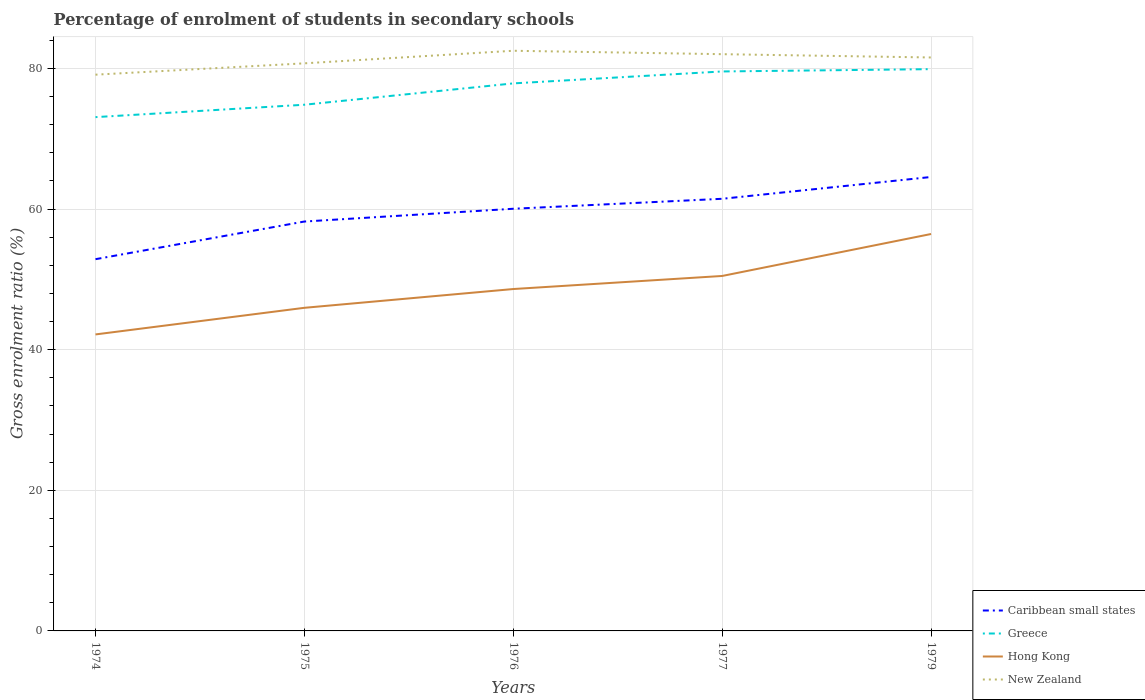How many different coloured lines are there?
Provide a short and direct response. 4. Does the line corresponding to New Zealand intersect with the line corresponding to Caribbean small states?
Offer a terse response. No. Is the number of lines equal to the number of legend labels?
Your response must be concise. Yes. Across all years, what is the maximum percentage of students enrolled in secondary schools in Greece?
Make the answer very short. 73.08. In which year was the percentage of students enrolled in secondary schools in Hong Kong maximum?
Provide a short and direct response. 1974. What is the total percentage of students enrolled in secondary schools in Caribbean small states in the graph?
Ensure brevity in your answer.  -1.42. What is the difference between the highest and the second highest percentage of students enrolled in secondary schools in New Zealand?
Give a very brief answer. 3.4. Is the percentage of students enrolled in secondary schools in Caribbean small states strictly greater than the percentage of students enrolled in secondary schools in Greece over the years?
Your answer should be compact. Yes. What is the difference between two consecutive major ticks on the Y-axis?
Provide a short and direct response. 20. Are the values on the major ticks of Y-axis written in scientific E-notation?
Offer a very short reply. No. Does the graph contain any zero values?
Provide a succinct answer. No. Does the graph contain grids?
Your answer should be compact. Yes. Where does the legend appear in the graph?
Give a very brief answer. Bottom right. How many legend labels are there?
Make the answer very short. 4. How are the legend labels stacked?
Offer a terse response. Vertical. What is the title of the graph?
Offer a terse response. Percentage of enrolment of students in secondary schools. Does "Sub-Saharan Africa (developing only)" appear as one of the legend labels in the graph?
Offer a terse response. No. What is the label or title of the X-axis?
Provide a succinct answer. Years. What is the label or title of the Y-axis?
Your response must be concise. Gross enrolment ratio (%). What is the Gross enrolment ratio (%) of Caribbean small states in 1974?
Provide a succinct answer. 52.88. What is the Gross enrolment ratio (%) in Greece in 1974?
Provide a succinct answer. 73.08. What is the Gross enrolment ratio (%) of Hong Kong in 1974?
Provide a short and direct response. 42.17. What is the Gross enrolment ratio (%) in New Zealand in 1974?
Your answer should be compact. 79.12. What is the Gross enrolment ratio (%) in Caribbean small states in 1975?
Provide a succinct answer. 58.23. What is the Gross enrolment ratio (%) in Greece in 1975?
Your response must be concise. 74.84. What is the Gross enrolment ratio (%) in Hong Kong in 1975?
Your response must be concise. 45.96. What is the Gross enrolment ratio (%) of New Zealand in 1975?
Keep it short and to the point. 80.73. What is the Gross enrolment ratio (%) of Caribbean small states in 1976?
Offer a terse response. 60.05. What is the Gross enrolment ratio (%) in Greece in 1976?
Your response must be concise. 77.88. What is the Gross enrolment ratio (%) of Hong Kong in 1976?
Provide a short and direct response. 48.63. What is the Gross enrolment ratio (%) of New Zealand in 1976?
Your answer should be compact. 82.52. What is the Gross enrolment ratio (%) of Caribbean small states in 1977?
Offer a very short reply. 61.46. What is the Gross enrolment ratio (%) in Greece in 1977?
Ensure brevity in your answer.  79.58. What is the Gross enrolment ratio (%) in Hong Kong in 1977?
Your answer should be very brief. 50.49. What is the Gross enrolment ratio (%) of New Zealand in 1977?
Your response must be concise. 82.03. What is the Gross enrolment ratio (%) of Caribbean small states in 1979?
Give a very brief answer. 64.57. What is the Gross enrolment ratio (%) in Greece in 1979?
Your response must be concise. 79.91. What is the Gross enrolment ratio (%) of Hong Kong in 1979?
Give a very brief answer. 56.46. What is the Gross enrolment ratio (%) in New Zealand in 1979?
Make the answer very short. 81.57. Across all years, what is the maximum Gross enrolment ratio (%) of Caribbean small states?
Your answer should be compact. 64.57. Across all years, what is the maximum Gross enrolment ratio (%) of Greece?
Give a very brief answer. 79.91. Across all years, what is the maximum Gross enrolment ratio (%) of Hong Kong?
Ensure brevity in your answer.  56.46. Across all years, what is the maximum Gross enrolment ratio (%) of New Zealand?
Give a very brief answer. 82.52. Across all years, what is the minimum Gross enrolment ratio (%) in Caribbean small states?
Provide a succinct answer. 52.88. Across all years, what is the minimum Gross enrolment ratio (%) in Greece?
Give a very brief answer. 73.08. Across all years, what is the minimum Gross enrolment ratio (%) in Hong Kong?
Offer a terse response. 42.17. Across all years, what is the minimum Gross enrolment ratio (%) in New Zealand?
Give a very brief answer. 79.12. What is the total Gross enrolment ratio (%) of Caribbean small states in the graph?
Make the answer very short. 297.19. What is the total Gross enrolment ratio (%) in Greece in the graph?
Offer a very short reply. 385.29. What is the total Gross enrolment ratio (%) of Hong Kong in the graph?
Your answer should be very brief. 243.71. What is the total Gross enrolment ratio (%) in New Zealand in the graph?
Ensure brevity in your answer.  405.97. What is the difference between the Gross enrolment ratio (%) in Caribbean small states in 1974 and that in 1975?
Make the answer very short. -5.36. What is the difference between the Gross enrolment ratio (%) of Greece in 1974 and that in 1975?
Keep it short and to the point. -1.76. What is the difference between the Gross enrolment ratio (%) of Hong Kong in 1974 and that in 1975?
Offer a terse response. -3.79. What is the difference between the Gross enrolment ratio (%) of New Zealand in 1974 and that in 1975?
Offer a terse response. -1.61. What is the difference between the Gross enrolment ratio (%) in Caribbean small states in 1974 and that in 1976?
Offer a terse response. -7.17. What is the difference between the Gross enrolment ratio (%) of Greece in 1974 and that in 1976?
Give a very brief answer. -4.8. What is the difference between the Gross enrolment ratio (%) of Hong Kong in 1974 and that in 1976?
Offer a very short reply. -6.46. What is the difference between the Gross enrolment ratio (%) in New Zealand in 1974 and that in 1976?
Offer a very short reply. -3.4. What is the difference between the Gross enrolment ratio (%) in Caribbean small states in 1974 and that in 1977?
Offer a very short reply. -8.59. What is the difference between the Gross enrolment ratio (%) in Greece in 1974 and that in 1977?
Give a very brief answer. -6.5. What is the difference between the Gross enrolment ratio (%) of Hong Kong in 1974 and that in 1977?
Give a very brief answer. -8.32. What is the difference between the Gross enrolment ratio (%) of New Zealand in 1974 and that in 1977?
Provide a short and direct response. -2.92. What is the difference between the Gross enrolment ratio (%) of Caribbean small states in 1974 and that in 1979?
Offer a terse response. -11.69. What is the difference between the Gross enrolment ratio (%) in Greece in 1974 and that in 1979?
Your response must be concise. -6.82. What is the difference between the Gross enrolment ratio (%) in Hong Kong in 1974 and that in 1979?
Your answer should be compact. -14.28. What is the difference between the Gross enrolment ratio (%) in New Zealand in 1974 and that in 1979?
Give a very brief answer. -2.45. What is the difference between the Gross enrolment ratio (%) in Caribbean small states in 1975 and that in 1976?
Your answer should be very brief. -1.82. What is the difference between the Gross enrolment ratio (%) in Greece in 1975 and that in 1976?
Offer a very short reply. -3.04. What is the difference between the Gross enrolment ratio (%) of Hong Kong in 1975 and that in 1976?
Your response must be concise. -2.67. What is the difference between the Gross enrolment ratio (%) in New Zealand in 1975 and that in 1976?
Keep it short and to the point. -1.79. What is the difference between the Gross enrolment ratio (%) in Caribbean small states in 1975 and that in 1977?
Give a very brief answer. -3.23. What is the difference between the Gross enrolment ratio (%) of Greece in 1975 and that in 1977?
Your answer should be compact. -4.73. What is the difference between the Gross enrolment ratio (%) in Hong Kong in 1975 and that in 1977?
Your response must be concise. -4.53. What is the difference between the Gross enrolment ratio (%) of New Zealand in 1975 and that in 1977?
Provide a short and direct response. -1.3. What is the difference between the Gross enrolment ratio (%) of Caribbean small states in 1975 and that in 1979?
Offer a terse response. -6.34. What is the difference between the Gross enrolment ratio (%) of Greece in 1975 and that in 1979?
Provide a short and direct response. -5.06. What is the difference between the Gross enrolment ratio (%) in Hong Kong in 1975 and that in 1979?
Provide a short and direct response. -10.5. What is the difference between the Gross enrolment ratio (%) of New Zealand in 1975 and that in 1979?
Make the answer very short. -0.83. What is the difference between the Gross enrolment ratio (%) in Caribbean small states in 1976 and that in 1977?
Your answer should be very brief. -1.42. What is the difference between the Gross enrolment ratio (%) in Greece in 1976 and that in 1977?
Offer a very short reply. -1.7. What is the difference between the Gross enrolment ratio (%) of Hong Kong in 1976 and that in 1977?
Offer a terse response. -1.86. What is the difference between the Gross enrolment ratio (%) of New Zealand in 1976 and that in 1977?
Your response must be concise. 0.49. What is the difference between the Gross enrolment ratio (%) in Caribbean small states in 1976 and that in 1979?
Offer a terse response. -4.52. What is the difference between the Gross enrolment ratio (%) in Greece in 1976 and that in 1979?
Your answer should be very brief. -2.03. What is the difference between the Gross enrolment ratio (%) in Hong Kong in 1976 and that in 1979?
Provide a short and direct response. -7.83. What is the difference between the Gross enrolment ratio (%) of New Zealand in 1976 and that in 1979?
Your answer should be compact. 0.96. What is the difference between the Gross enrolment ratio (%) of Caribbean small states in 1977 and that in 1979?
Provide a short and direct response. -3.1. What is the difference between the Gross enrolment ratio (%) of Greece in 1977 and that in 1979?
Ensure brevity in your answer.  -0.33. What is the difference between the Gross enrolment ratio (%) of Hong Kong in 1977 and that in 1979?
Your response must be concise. -5.97. What is the difference between the Gross enrolment ratio (%) in New Zealand in 1977 and that in 1979?
Provide a short and direct response. 0.47. What is the difference between the Gross enrolment ratio (%) of Caribbean small states in 1974 and the Gross enrolment ratio (%) of Greece in 1975?
Give a very brief answer. -21.97. What is the difference between the Gross enrolment ratio (%) of Caribbean small states in 1974 and the Gross enrolment ratio (%) of Hong Kong in 1975?
Offer a very short reply. 6.92. What is the difference between the Gross enrolment ratio (%) of Caribbean small states in 1974 and the Gross enrolment ratio (%) of New Zealand in 1975?
Ensure brevity in your answer.  -27.86. What is the difference between the Gross enrolment ratio (%) of Greece in 1974 and the Gross enrolment ratio (%) of Hong Kong in 1975?
Offer a terse response. 27.12. What is the difference between the Gross enrolment ratio (%) in Greece in 1974 and the Gross enrolment ratio (%) in New Zealand in 1975?
Offer a terse response. -7.65. What is the difference between the Gross enrolment ratio (%) of Hong Kong in 1974 and the Gross enrolment ratio (%) of New Zealand in 1975?
Make the answer very short. -38.56. What is the difference between the Gross enrolment ratio (%) of Caribbean small states in 1974 and the Gross enrolment ratio (%) of Greece in 1976?
Your answer should be very brief. -25. What is the difference between the Gross enrolment ratio (%) in Caribbean small states in 1974 and the Gross enrolment ratio (%) in Hong Kong in 1976?
Offer a terse response. 4.24. What is the difference between the Gross enrolment ratio (%) in Caribbean small states in 1974 and the Gross enrolment ratio (%) in New Zealand in 1976?
Provide a short and direct response. -29.65. What is the difference between the Gross enrolment ratio (%) in Greece in 1974 and the Gross enrolment ratio (%) in Hong Kong in 1976?
Make the answer very short. 24.45. What is the difference between the Gross enrolment ratio (%) in Greece in 1974 and the Gross enrolment ratio (%) in New Zealand in 1976?
Provide a short and direct response. -9.44. What is the difference between the Gross enrolment ratio (%) of Hong Kong in 1974 and the Gross enrolment ratio (%) of New Zealand in 1976?
Keep it short and to the point. -40.35. What is the difference between the Gross enrolment ratio (%) in Caribbean small states in 1974 and the Gross enrolment ratio (%) in Greece in 1977?
Your answer should be compact. -26.7. What is the difference between the Gross enrolment ratio (%) in Caribbean small states in 1974 and the Gross enrolment ratio (%) in Hong Kong in 1977?
Make the answer very short. 2.39. What is the difference between the Gross enrolment ratio (%) in Caribbean small states in 1974 and the Gross enrolment ratio (%) in New Zealand in 1977?
Your answer should be compact. -29.16. What is the difference between the Gross enrolment ratio (%) in Greece in 1974 and the Gross enrolment ratio (%) in Hong Kong in 1977?
Keep it short and to the point. 22.59. What is the difference between the Gross enrolment ratio (%) of Greece in 1974 and the Gross enrolment ratio (%) of New Zealand in 1977?
Make the answer very short. -8.95. What is the difference between the Gross enrolment ratio (%) of Hong Kong in 1974 and the Gross enrolment ratio (%) of New Zealand in 1977?
Give a very brief answer. -39.86. What is the difference between the Gross enrolment ratio (%) in Caribbean small states in 1974 and the Gross enrolment ratio (%) in Greece in 1979?
Your response must be concise. -27.03. What is the difference between the Gross enrolment ratio (%) in Caribbean small states in 1974 and the Gross enrolment ratio (%) in Hong Kong in 1979?
Provide a short and direct response. -3.58. What is the difference between the Gross enrolment ratio (%) in Caribbean small states in 1974 and the Gross enrolment ratio (%) in New Zealand in 1979?
Your response must be concise. -28.69. What is the difference between the Gross enrolment ratio (%) of Greece in 1974 and the Gross enrolment ratio (%) of Hong Kong in 1979?
Offer a very short reply. 16.62. What is the difference between the Gross enrolment ratio (%) in Greece in 1974 and the Gross enrolment ratio (%) in New Zealand in 1979?
Your answer should be compact. -8.48. What is the difference between the Gross enrolment ratio (%) in Hong Kong in 1974 and the Gross enrolment ratio (%) in New Zealand in 1979?
Your answer should be very brief. -39.39. What is the difference between the Gross enrolment ratio (%) of Caribbean small states in 1975 and the Gross enrolment ratio (%) of Greece in 1976?
Your answer should be very brief. -19.65. What is the difference between the Gross enrolment ratio (%) of Caribbean small states in 1975 and the Gross enrolment ratio (%) of Hong Kong in 1976?
Keep it short and to the point. 9.6. What is the difference between the Gross enrolment ratio (%) in Caribbean small states in 1975 and the Gross enrolment ratio (%) in New Zealand in 1976?
Your answer should be very brief. -24.29. What is the difference between the Gross enrolment ratio (%) in Greece in 1975 and the Gross enrolment ratio (%) in Hong Kong in 1976?
Offer a terse response. 26.21. What is the difference between the Gross enrolment ratio (%) of Greece in 1975 and the Gross enrolment ratio (%) of New Zealand in 1976?
Make the answer very short. -7.68. What is the difference between the Gross enrolment ratio (%) in Hong Kong in 1975 and the Gross enrolment ratio (%) in New Zealand in 1976?
Make the answer very short. -36.56. What is the difference between the Gross enrolment ratio (%) in Caribbean small states in 1975 and the Gross enrolment ratio (%) in Greece in 1977?
Your response must be concise. -21.35. What is the difference between the Gross enrolment ratio (%) in Caribbean small states in 1975 and the Gross enrolment ratio (%) in Hong Kong in 1977?
Ensure brevity in your answer.  7.74. What is the difference between the Gross enrolment ratio (%) in Caribbean small states in 1975 and the Gross enrolment ratio (%) in New Zealand in 1977?
Your answer should be very brief. -23.8. What is the difference between the Gross enrolment ratio (%) in Greece in 1975 and the Gross enrolment ratio (%) in Hong Kong in 1977?
Provide a short and direct response. 24.36. What is the difference between the Gross enrolment ratio (%) in Greece in 1975 and the Gross enrolment ratio (%) in New Zealand in 1977?
Your response must be concise. -7.19. What is the difference between the Gross enrolment ratio (%) of Hong Kong in 1975 and the Gross enrolment ratio (%) of New Zealand in 1977?
Your response must be concise. -36.08. What is the difference between the Gross enrolment ratio (%) in Caribbean small states in 1975 and the Gross enrolment ratio (%) in Greece in 1979?
Provide a succinct answer. -21.67. What is the difference between the Gross enrolment ratio (%) in Caribbean small states in 1975 and the Gross enrolment ratio (%) in Hong Kong in 1979?
Provide a short and direct response. 1.77. What is the difference between the Gross enrolment ratio (%) of Caribbean small states in 1975 and the Gross enrolment ratio (%) of New Zealand in 1979?
Keep it short and to the point. -23.33. What is the difference between the Gross enrolment ratio (%) of Greece in 1975 and the Gross enrolment ratio (%) of Hong Kong in 1979?
Your answer should be compact. 18.39. What is the difference between the Gross enrolment ratio (%) of Greece in 1975 and the Gross enrolment ratio (%) of New Zealand in 1979?
Give a very brief answer. -6.72. What is the difference between the Gross enrolment ratio (%) in Hong Kong in 1975 and the Gross enrolment ratio (%) in New Zealand in 1979?
Keep it short and to the point. -35.61. What is the difference between the Gross enrolment ratio (%) in Caribbean small states in 1976 and the Gross enrolment ratio (%) in Greece in 1977?
Give a very brief answer. -19.53. What is the difference between the Gross enrolment ratio (%) in Caribbean small states in 1976 and the Gross enrolment ratio (%) in Hong Kong in 1977?
Your answer should be compact. 9.56. What is the difference between the Gross enrolment ratio (%) in Caribbean small states in 1976 and the Gross enrolment ratio (%) in New Zealand in 1977?
Offer a very short reply. -21.99. What is the difference between the Gross enrolment ratio (%) of Greece in 1976 and the Gross enrolment ratio (%) of Hong Kong in 1977?
Your answer should be very brief. 27.39. What is the difference between the Gross enrolment ratio (%) in Greece in 1976 and the Gross enrolment ratio (%) in New Zealand in 1977?
Your answer should be compact. -4.16. What is the difference between the Gross enrolment ratio (%) in Hong Kong in 1976 and the Gross enrolment ratio (%) in New Zealand in 1977?
Keep it short and to the point. -33.4. What is the difference between the Gross enrolment ratio (%) in Caribbean small states in 1976 and the Gross enrolment ratio (%) in Greece in 1979?
Your answer should be very brief. -19.86. What is the difference between the Gross enrolment ratio (%) in Caribbean small states in 1976 and the Gross enrolment ratio (%) in Hong Kong in 1979?
Keep it short and to the point. 3.59. What is the difference between the Gross enrolment ratio (%) in Caribbean small states in 1976 and the Gross enrolment ratio (%) in New Zealand in 1979?
Provide a succinct answer. -21.52. What is the difference between the Gross enrolment ratio (%) of Greece in 1976 and the Gross enrolment ratio (%) of Hong Kong in 1979?
Provide a succinct answer. 21.42. What is the difference between the Gross enrolment ratio (%) in Greece in 1976 and the Gross enrolment ratio (%) in New Zealand in 1979?
Provide a short and direct response. -3.69. What is the difference between the Gross enrolment ratio (%) of Hong Kong in 1976 and the Gross enrolment ratio (%) of New Zealand in 1979?
Your response must be concise. -32.94. What is the difference between the Gross enrolment ratio (%) in Caribbean small states in 1977 and the Gross enrolment ratio (%) in Greece in 1979?
Give a very brief answer. -18.44. What is the difference between the Gross enrolment ratio (%) of Caribbean small states in 1977 and the Gross enrolment ratio (%) of Hong Kong in 1979?
Keep it short and to the point. 5.01. What is the difference between the Gross enrolment ratio (%) of Caribbean small states in 1977 and the Gross enrolment ratio (%) of New Zealand in 1979?
Offer a terse response. -20.1. What is the difference between the Gross enrolment ratio (%) in Greece in 1977 and the Gross enrolment ratio (%) in Hong Kong in 1979?
Provide a short and direct response. 23.12. What is the difference between the Gross enrolment ratio (%) of Greece in 1977 and the Gross enrolment ratio (%) of New Zealand in 1979?
Keep it short and to the point. -1.99. What is the difference between the Gross enrolment ratio (%) in Hong Kong in 1977 and the Gross enrolment ratio (%) in New Zealand in 1979?
Offer a very short reply. -31.08. What is the average Gross enrolment ratio (%) of Caribbean small states per year?
Offer a very short reply. 59.44. What is the average Gross enrolment ratio (%) in Greece per year?
Provide a succinct answer. 77.06. What is the average Gross enrolment ratio (%) in Hong Kong per year?
Ensure brevity in your answer.  48.74. What is the average Gross enrolment ratio (%) of New Zealand per year?
Offer a terse response. 81.19. In the year 1974, what is the difference between the Gross enrolment ratio (%) in Caribbean small states and Gross enrolment ratio (%) in Greece?
Ensure brevity in your answer.  -20.21. In the year 1974, what is the difference between the Gross enrolment ratio (%) of Caribbean small states and Gross enrolment ratio (%) of Hong Kong?
Give a very brief answer. 10.7. In the year 1974, what is the difference between the Gross enrolment ratio (%) in Caribbean small states and Gross enrolment ratio (%) in New Zealand?
Your answer should be very brief. -26.24. In the year 1974, what is the difference between the Gross enrolment ratio (%) in Greece and Gross enrolment ratio (%) in Hong Kong?
Provide a short and direct response. 30.91. In the year 1974, what is the difference between the Gross enrolment ratio (%) of Greece and Gross enrolment ratio (%) of New Zealand?
Make the answer very short. -6.04. In the year 1974, what is the difference between the Gross enrolment ratio (%) of Hong Kong and Gross enrolment ratio (%) of New Zealand?
Your answer should be very brief. -36.95. In the year 1975, what is the difference between the Gross enrolment ratio (%) of Caribbean small states and Gross enrolment ratio (%) of Greece?
Your answer should be compact. -16.61. In the year 1975, what is the difference between the Gross enrolment ratio (%) of Caribbean small states and Gross enrolment ratio (%) of Hong Kong?
Your response must be concise. 12.27. In the year 1975, what is the difference between the Gross enrolment ratio (%) in Caribbean small states and Gross enrolment ratio (%) in New Zealand?
Make the answer very short. -22.5. In the year 1975, what is the difference between the Gross enrolment ratio (%) in Greece and Gross enrolment ratio (%) in Hong Kong?
Make the answer very short. 28.89. In the year 1975, what is the difference between the Gross enrolment ratio (%) of Greece and Gross enrolment ratio (%) of New Zealand?
Offer a very short reply. -5.89. In the year 1975, what is the difference between the Gross enrolment ratio (%) in Hong Kong and Gross enrolment ratio (%) in New Zealand?
Offer a terse response. -34.77. In the year 1976, what is the difference between the Gross enrolment ratio (%) in Caribbean small states and Gross enrolment ratio (%) in Greece?
Keep it short and to the point. -17.83. In the year 1976, what is the difference between the Gross enrolment ratio (%) of Caribbean small states and Gross enrolment ratio (%) of Hong Kong?
Ensure brevity in your answer.  11.42. In the year 1976, what is the difference between the Gross enrolment ratio (%) of Caribbean small states and Gross enrolment ratio (%) of New Zealand?
Ensure brevity in your answer.  -22.47. In the year 1976, what is the difference between the Gross enrolment ratio (%) in Greece and Gross enrolment ratio (%) in Hong Kong?
Provide a succinct answer. 29.25. In the year 1976, what is the difference between the Gross enrolment ratio (%) of Greece and Gross enrolment ratio (%) of New Zealand?
Provide a succinct answer. -4.64. In the year 1976, what is the difference between the Gross enrolment ratio (%) in Hong Kong and Gross enrolment ratio (%) in New Zealand?
Your answer should be compact. -33.89. In the year 1977, what is the difference between the Gross enrolment ratio (%) in Caribbean small states and Gross enrolment ratio (%) in Greece?
Give a very brief answer. -18.11. In the year 1977, what is the difference between the Gross enrolment ratio (%) of Caribbean small states and Gross enrolment ratio (%) of Hong Kong?
Your answer should be compact. 10.98. In the year 1977, what is the difference between the Gross enrolment ratio (%) of Caribbean small states and Gross enrolment ratio (%) of New Zealand?
Give a very brief answer. -20.57. In the year 1977, what is the difference between the Gross enrolment ratio (%) in Greece and Gross enrolment ratio (%) in Hong Kong?
Keep it short and to the point. 29.09. In the year 1977, what is the difference between the Gross enrolment ratio (%) in Greece and Gross enrolment ratio (%) in New Zealand?
Provide a succinct answer. -2.46. In the year 1977, what is the difference between the Gross enrolment ratio (%) of Hong Kong and Gross enrolment ratio (%) of New Zealand?
Your response must be concise. -31.55. In the year 1979, what is the difference between the Gross enrolment ratio (%) in Caribbean small states and Gross enrolment ratio (%) in Greece?
Give a very brief answer. -15.34. In the year 1979, what is the difference between the Gross enrolment ratio (%) of Caribbean small states and Gross enrolment ratio (%) of Hong Kong?
Keep it short and to the point. 8.11. In the year 1979, what is the difference between the Gross enrolment ratio (%) in Caribbean small states and Gross enrolment ratio (%) in New Zealand?
Ensure brevity in your answer.  -17. In the year 1979, what is the difference between the Gross enrolment ratio (%) of Greece and Gross enrolment ratio (%) of Hong Kong?
Give a very brief answer. 23.45. In the year 1979, what is the difference between the Gross enrolment ratio (%) of Greece and Gross enrolment ratio (%) of New Zealand?
Offer a terse response. -1.66. In the year 1979, what is the difference between the Gross enrolment ratio (%) in Hong Kong and Gross enrolment ratio (%) in New Zealand?
Keep it short and to the point. -25.11. What is the ratio of the Gross enrolment ratio (%) in Caribbean small states in 1974 to that in 1975?
Your response must be concise. 0.91. What is the ratio of the Gross enrolment ratio (%) of Greece in 1974 to that in 1975?
Ensure brevity in your answer.  0.98. What is the ratio of the Gross enrolment ratio (%) in Hong Kong in 1974 to that in 1975?
Your answer should be very brief. 0.92. What is the ratio of the Gross enrolment ratio (%) in Caribbean small states in 1974 to that in 1976?
Offer a very short reply. 0.88. What is the ratio of the Gross enrolment ratio (%) in Greece in 1974 to that in 1976?
Keep it short and to the point. 0.94. What is the ratio of the Gross enrolment ratio (%) in Hong Kong in 1974 to that in 1976?
Your response must be concise. 0.87. What is the ratio of the Gross enrolment ratio (%) of New Zealand in 1974 to that in 1976?
Provide a short and direct response. 0.96. What is the ratio of the Gross enrolment ratio (%) in Caribbean small states in 1974 to that in 1977?
Your response must be concise. 0.86. What is the ratio of the Gross enrolment ratio (%) in Greece in 1974 to that in 1977?
Ensure brevity in your answer.  0.92. What is the ratio of the Gross enrolment ratio (%) of Hong Kong in 1974 to that in 1977?
Provide a short and direct response. 0.84. What is the ratio of the Gross enrolment ratio (%) of New Zealand in 1974 to that in 1977?
Provide a succinct answer. 0.96. What is the ratio of the Gross enrolment ratio (%) in Caribbean small states in 1974 to that in 1979?
Your response must be concise. 0.82. What is the ratio of the Gross enrolment ratio (%) of Greece in 1974 to that in 1979?
Keep it short and to the point. 0.91. What is the ratio of the Gross enrolment ratio (%) in Hong Kong in 1974 to that in 1979?
Offer a very short reply. 0.75. What is the ratio of the Gross enrolment ratio (%) in Caribbean small states in 1975 to that in 1976?
Offer a very short reply. 0.97. What is the ratio of the Gross enrolment ratio (%) in Greece in 1975 to that in 1976?
Provide a short and direct response. 0.96. What is the ratio of the Gross enrolment ratio (%) of Hong Kong in 1975 to that in 1976?
Provide a succinct answer. 0.95. What is the ratio of the Gross enrolment ratio (%) of New Zealand in 1975 to that in 1976?
Ensure brevity in your answer.  0.98. What is the ratio of the Gross enrolment ratio (%) in Caribbean small states in 1975 to that in 1977?
Offer a terse response. 0.95. What is the ratio of the Gross enrolment ratio (%) in Greece in 1975 to that in 1977?
Keep it short and to the point. 0.94. What is the ratio of the Gross enrolment ratio (%) of Hong Kong in 1975 to that in 1977?
Your answer should be compact. 0.91. What is the ratio of the Gross enrolment ratio (%) of New Zealand in 1975 to that in 1977?
Provide a short and direct response. 0.98. What is the ratio of the Gross enrolment ratio (%) of Caribbean small states in 1975 to that in 1979?
Provide a succinct answer. 0.9. What is the ratio of the Gross enrolment ratio (%) of Greece in 1975 to that in 1979?
Provide a short and direct response. 0.94. What is the ratio of the Gross enrolment ratio (%) of Hong Kong in 1975 to that in 1979?
Make the answer very short. 0.81. What is the ratio of the Gross enrolment ratio (%) of New Zealand in 1975 to that in 1979?
Keep it short and to the point. 0.99. What is the ratio of the Gross enrolment ratio (%) in Greece in 1976 to that in 1977?
Provide a short and direct response. 0.98. What is the ratio of the Gross enrolment ratio (%) of Hong Kong in 1976 to that in 1977?
Offer a very short reply. 0.96. What is the ratio of the Gross enrolment ratio (%) in New Zealand in 1976 to that in 1977?
Provide a succinct answer. 1.01. What is the ratio of the Gross enrolment ratio (%) in Caribbean small states in 1976 to that in 1979?
Your answer should be compact. 0.93. What is the ratio of the Gross enrolment ratio (%) of Greece in 1976 to that in 1979?
Provide a succinct answer. 0.97. What is the ratio of the Gross enrolment ratio (%) of Hong Kong in 1976 to that in 1979?
Provide a succinct answer. 0.86. What is the ratio of the Gross enrolment ratio (%) of New Zealand in 1976 to that in 1979?
Offer a terse response. 1.01. What is the ratio of the Gross enrolment ratio (%) in Caribbean small states in 1977 to that in 1979?
Your answer should be very brief. 0.95. What is the ratio of the Gross enrolment ratio (%) in Hong Kong in 1977 to that in 1979?
Your response must be concise. 0.89. What is the ratio of the Gross enrolment ratio (%) in New Zealand in 1977 to that in 1979?
Keep it short and to the point. 1.01. What is the difference between the highest and the second highest Gross enrolment ratio (%) in Caribbean small states?
Your answer should be very brief. 3.1. What is the difference between the highest and the second highest Gross enrolment ratio (%) of Greece?
Ensure brevity in your answer.  0.33. What is the difference between the highest and the second highest Gross enrolment ratio (%) of Hong Kong?
Your answer should be compact. 5.97. What is the difference between the highest and the second highest Gross enrolment ratio (%) in New Zealand?
Your answer should be very brief. 0.49. What is the difference between the highest and the lowest Gross enrolment ratio (%) of Caribbean small states?
Ensure brevity in your answer.  11.69. What is the difference between the highest and the lowest Gross enrolment ratio (%) in Greece?
Keep it short and to the point. 6.82. What is the difference between the highest and the lowest Gross enrolment ratio (%) of Hong Kong?
Ensure brevity in your answer.  14.28. What is the difference between the highest and the lowest Gross enrolment ratio (%) of New Zealand?
Make the answer very short. 3.4. 